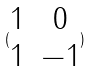<formula> <loc_0><loc_0><loc_500><loc_500>( \begin{matrix} 1 & 0 \\ 1 & - 1 \end{matrix} )</formula> 